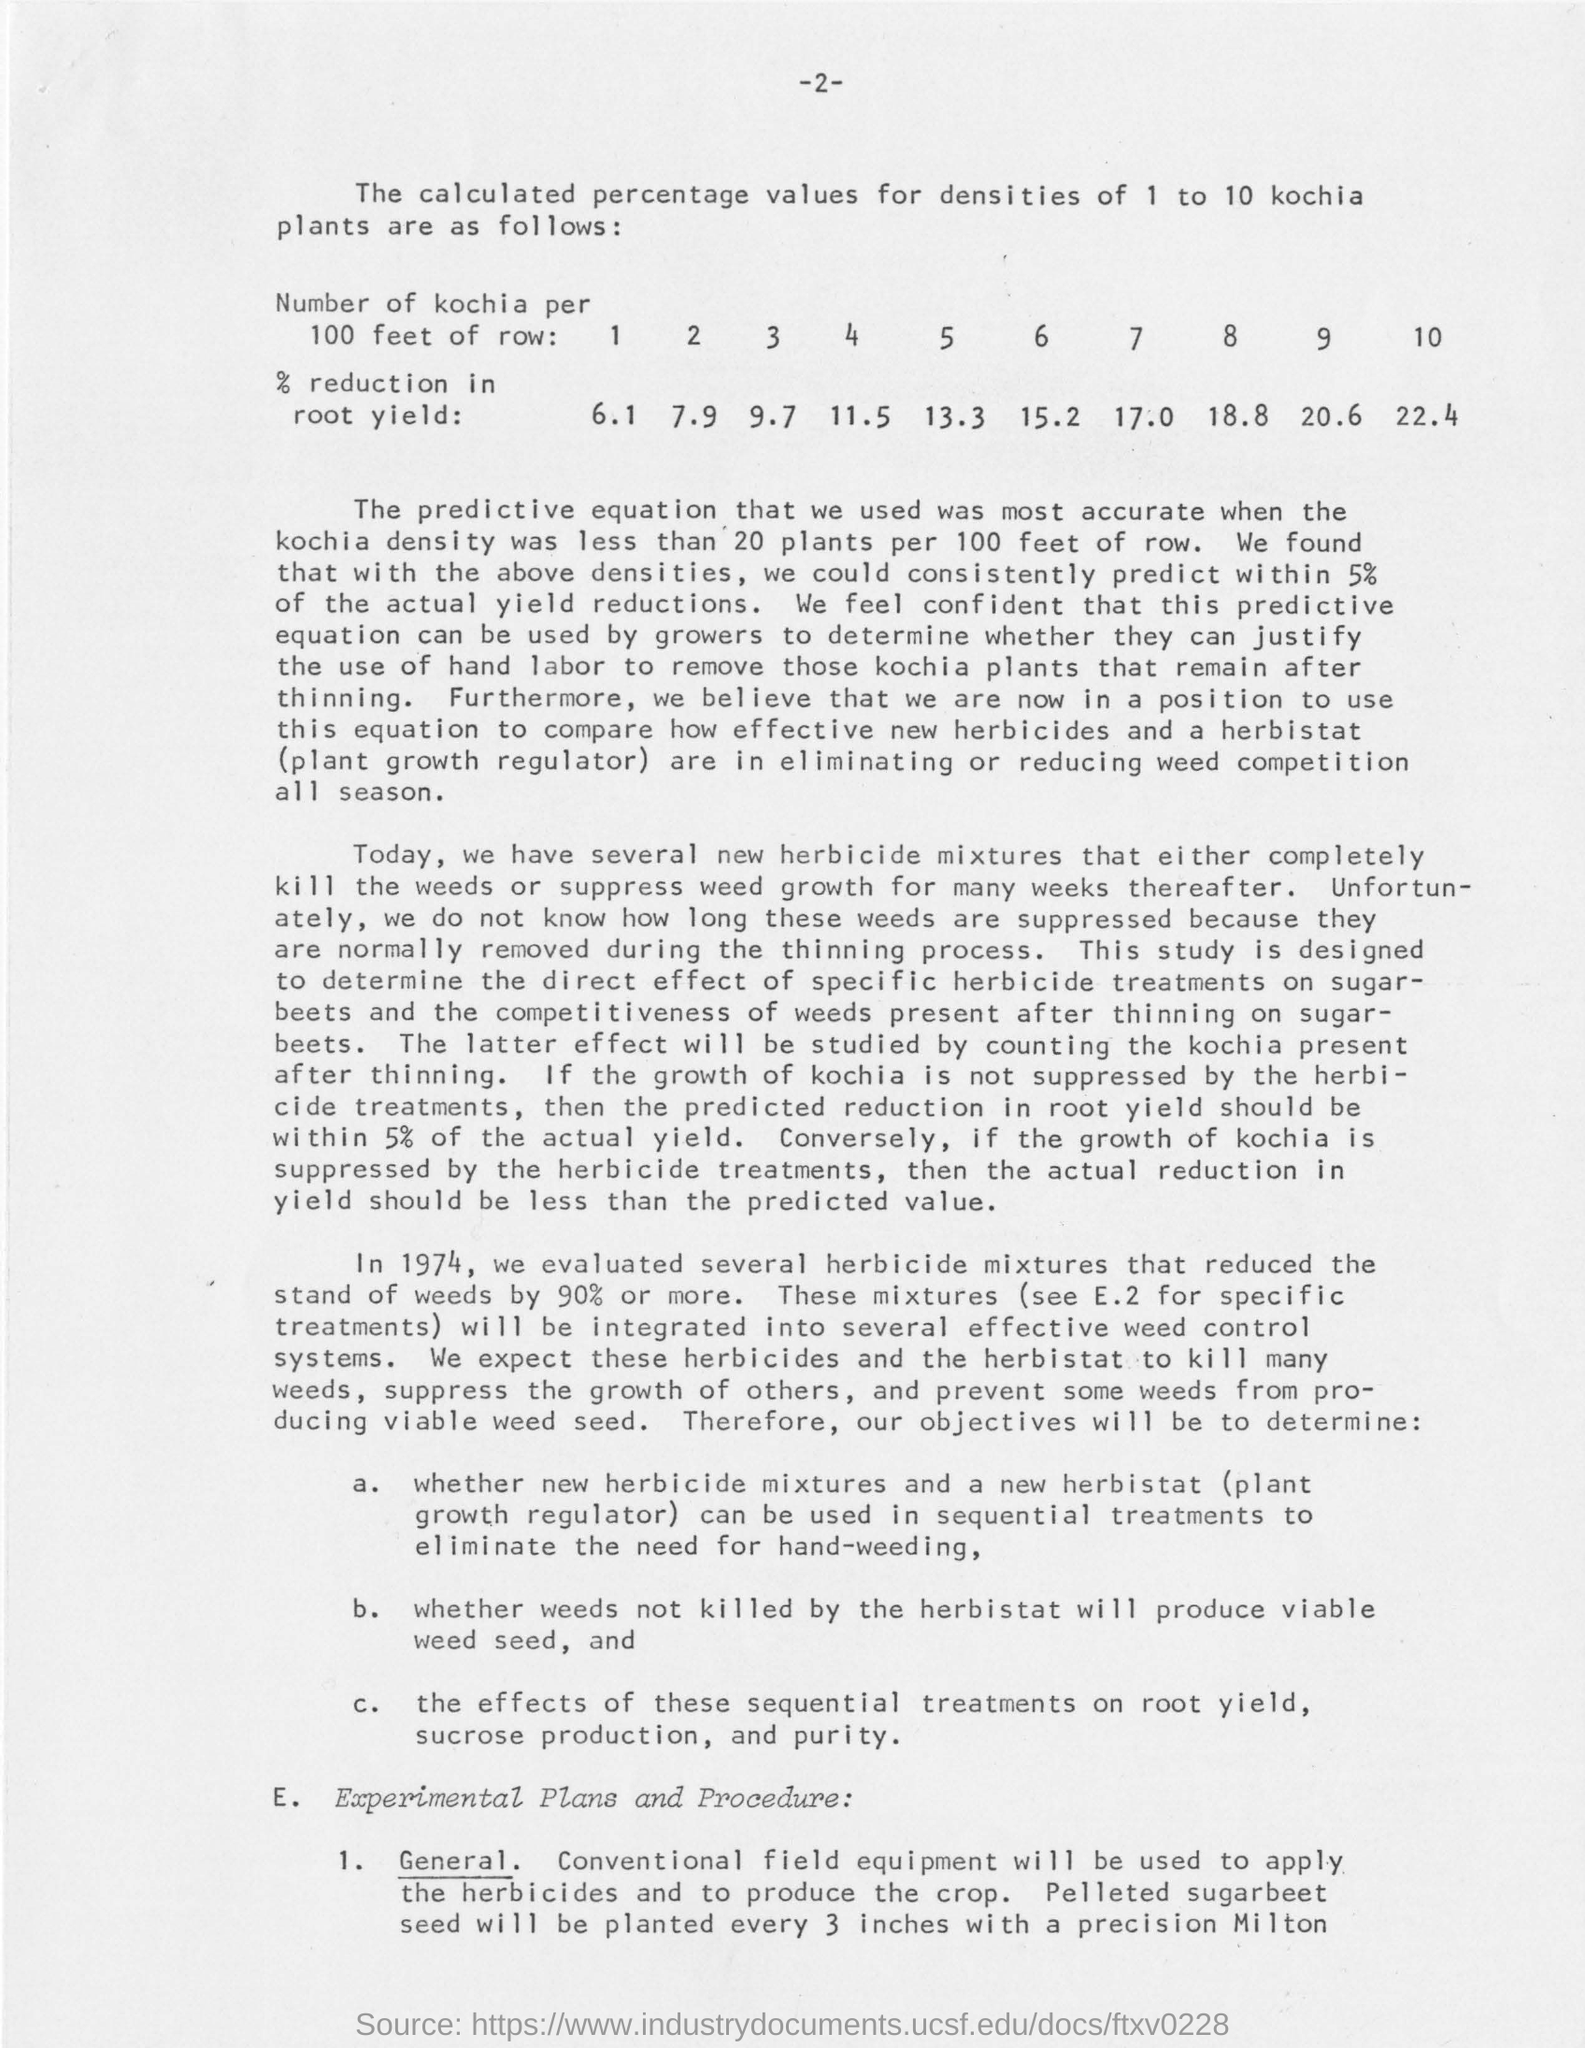How much rate of reduction in root yield for the 4 kochi plants per 100 feet of row for densities value?
Keep it short and to the point. 11.5. In which year was several herbicide mixtures that reduced the stand of weeds by 90% or more were tested?
Give a very brief answer. 1974. How much rate of stand of weeds are reduced when several herbicides mixtures are evaluated in 1974?
Give a very brief answer. 90%. How much rate of actual yield reductions are within as per consistenly prediction from calculated densities
Your response must be concise. Within 5%. 